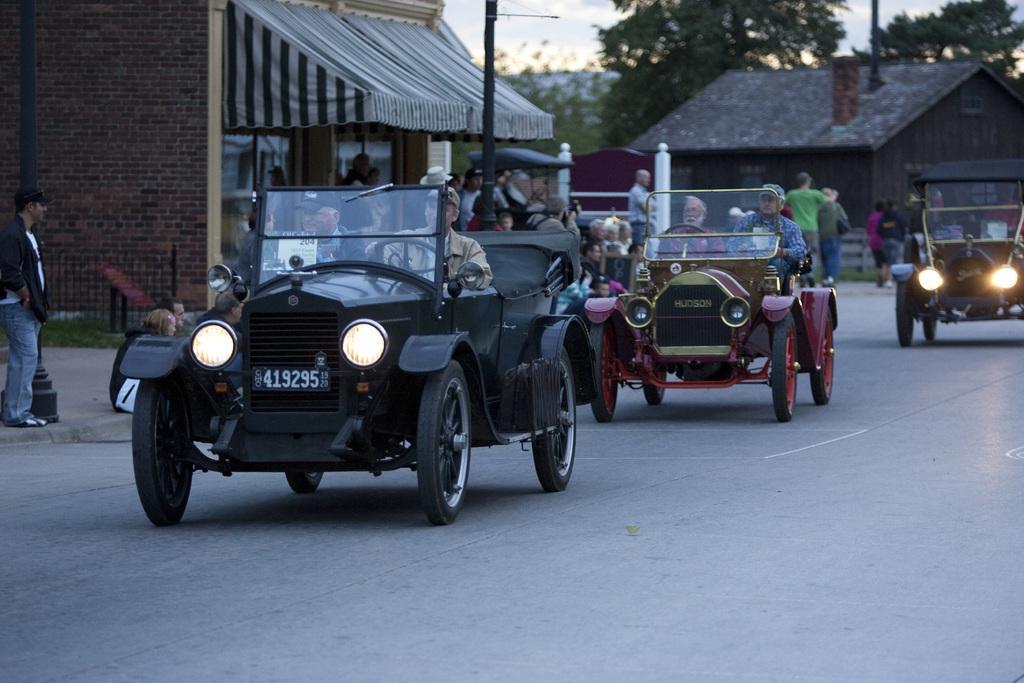Describe this image in one or two sentences. This image is clicked on the road. There are vehicles moving on the road. There are people sitting in the vehicles. Beside the road there is a walkway. There are people standing on the walkway. There are poles and grass on the walkway. In the background there are houses and trees. At the top there is the sky. 